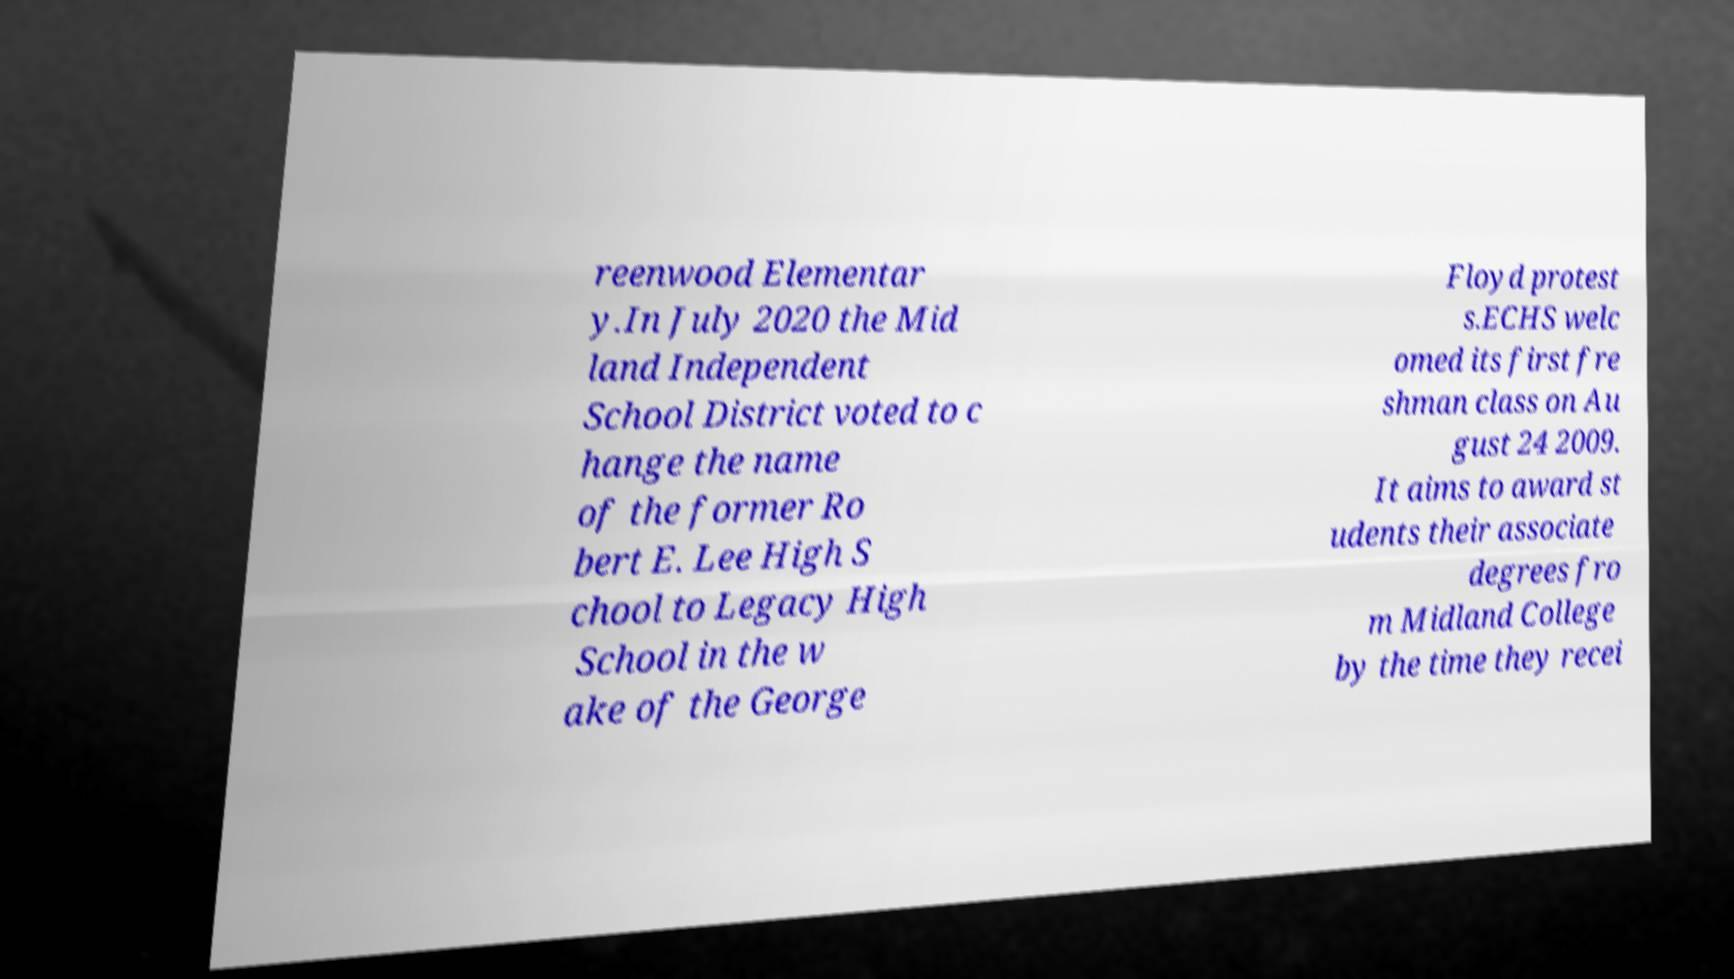Can you accurately transcribe the text from the provided image for me? reenwood Elementar y.In July 2020 the Mid land Independent School District voted to c hange the name of the former Ro bert E. Lee High S chool to Legacy High School in the w ake of the George Floyd protest s.ECHS welc omed its first fre shman class on Au gust 24 2009. It aims to award st udents their associate degrees fro m Midland College by the time they recei 